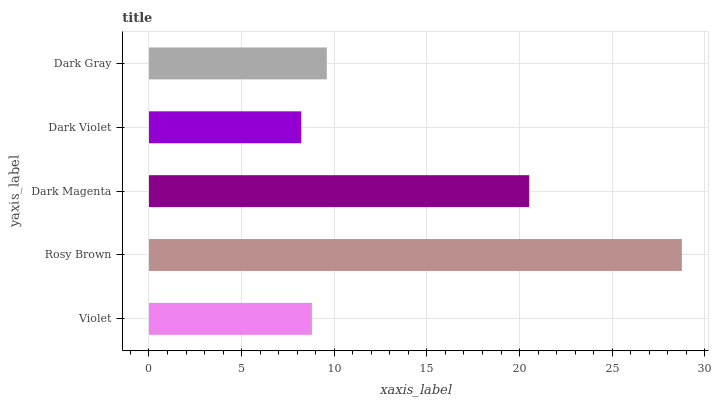Is Dark Violet the minimum?
Answer yes or no. Yes. Is Rosy Brown the maximum?
Answer yes or no. Yes. Is Dark Magenta the minimum?
Answer yes or no. No. Is Dark Magenta the maximum?
Answer yes or no. No. Is Rosy Brown greater than Dark Magenta?
Answer yes or no. Yes. Is Dark Magenta less than Rosy Brown?
Answer yes or no. Yes. Is Dark Magenta greater than Rosy Brown?
Answer yes or no. No. Is Rosy Brown less than Dark Magenta?
Answer yes or no. No. Is Dark Gray the high median?
Answer yes or no. Yes. Is Dark Gray the low median?
Answer yes or no. Yes. Is Violet the high median?
Answer yes or no. No. Is Dark Violet the low median?
Answer yes or no. No. 